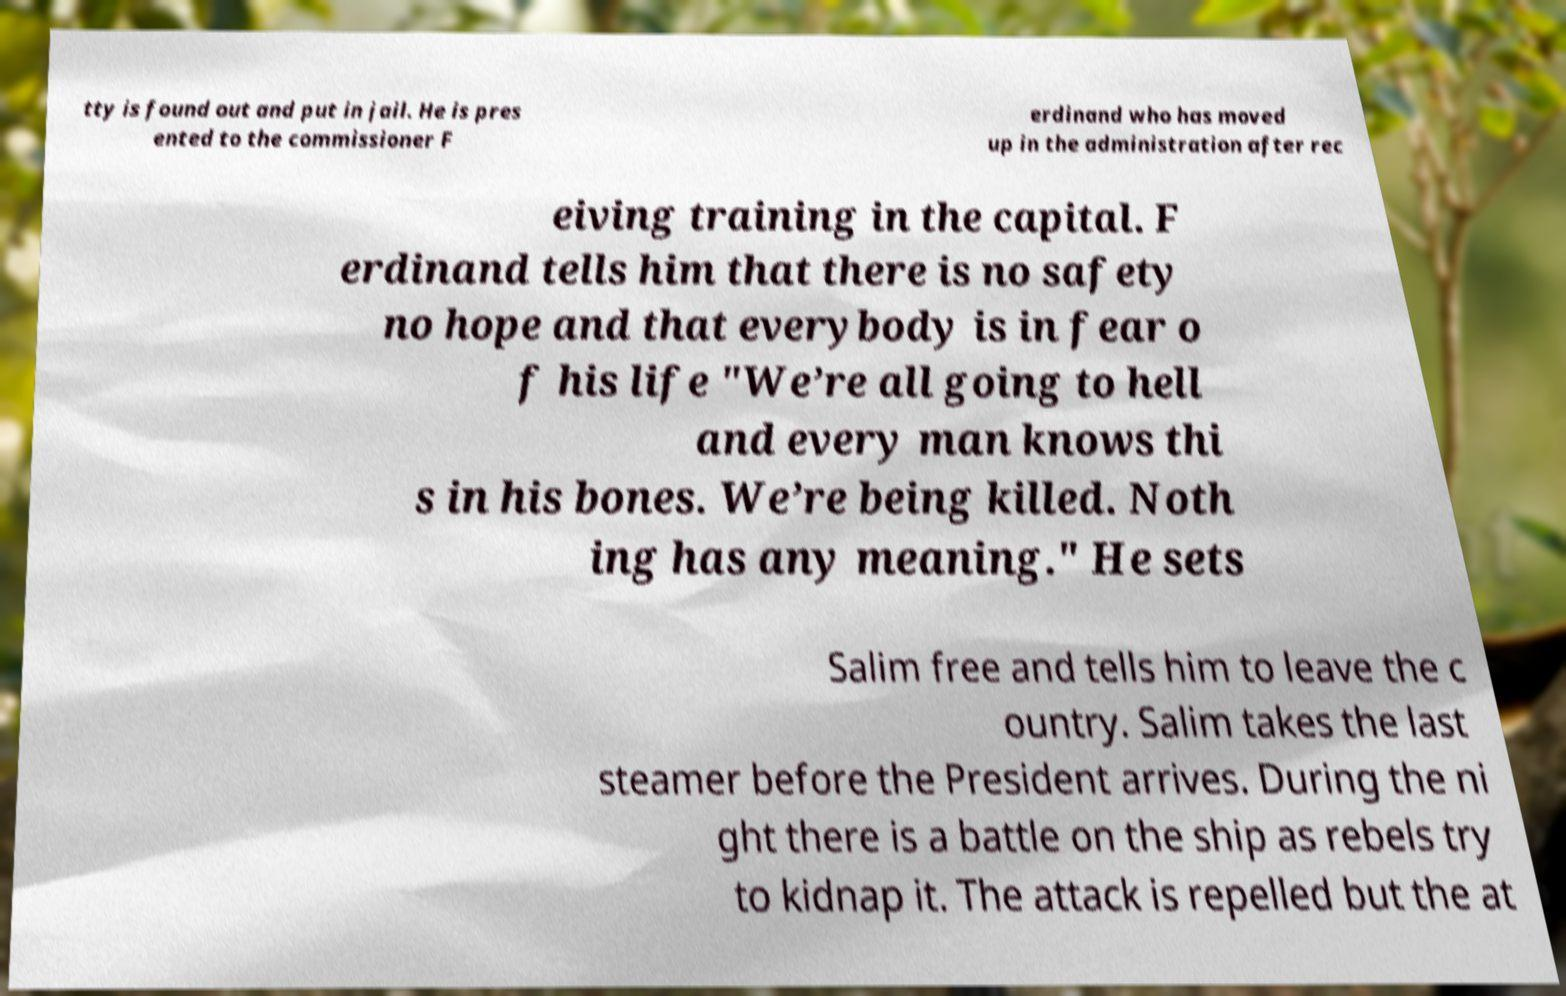There's text embedded in this image that I need extracted. Can you transcribe it verbatim? tty is found out and put in jail. He is pres ented to the commissioner F erdinand who has moved up in the administration after rec eiving training in the capital. F erdinand tells him that there is no safety no hope and that everybody is in fear o f his life "We’re all going to hell and every man knows thi s in his bones. We’re being killed. Noth ing has any meaning." He sets Salim free and tells him to leave the c ountry. Salim takes the last steamer before the President arrives. During the ni ght there is a battle on the ship as rebels try to kidnap it. The attack is repelled but the at 